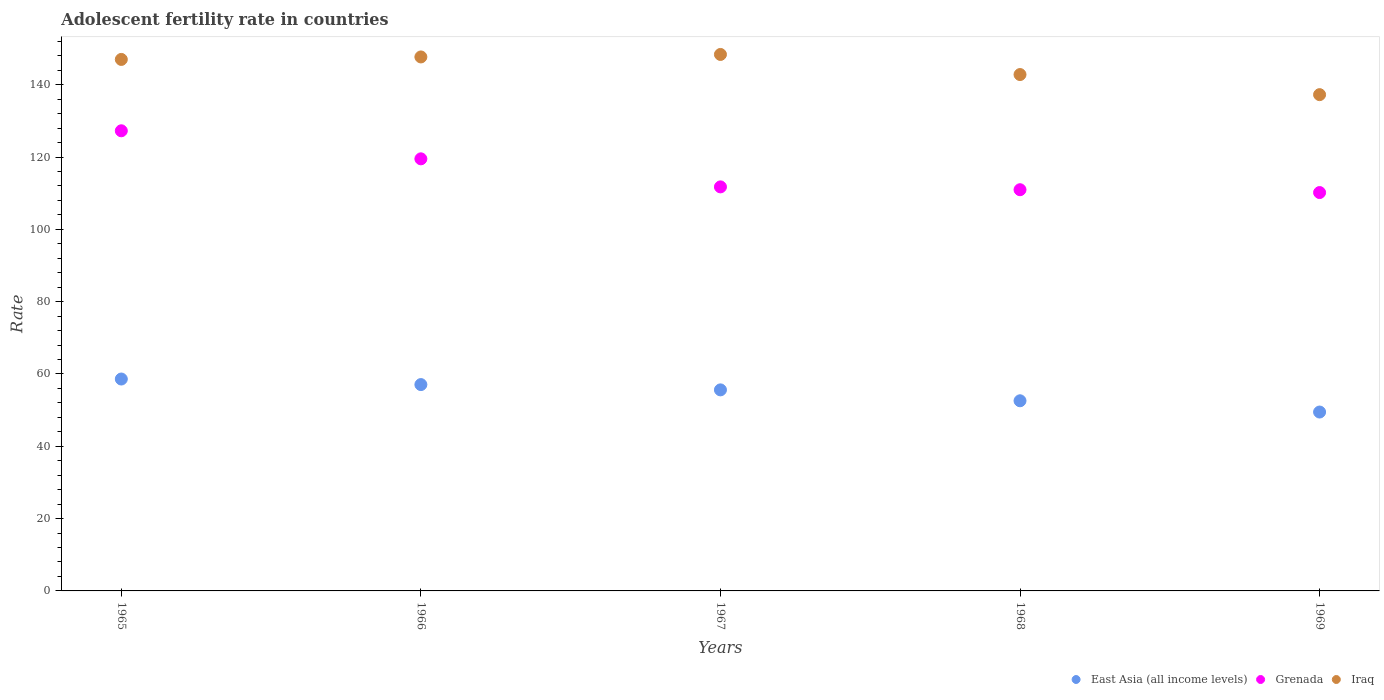What is the adolescent fertility rate in Grenada in 1967?
Provide a succinct answer. 111.74. Across all years, what is the maximum adolescent fertility rate in Grenada?
Your answer should be very brief. 127.26. Across all years, what is the minimum adolescent fertility rate in Iraq?
Your answer should be very brief. 137.25. In which year was the adolescent fertility rate in East Asia (all income levels) maximum?
Offer a very short reply. 1965. In which year was the adolescent fertility rate in Grenada minimum?
Offer a terse response. 1969. What is the total adolescent fertility rate in East Asia (all income levels) in the graph?
Provide a short and direct response. 273.33. What is the difference between the adolescent fertility rate in Grenada in 1965 and that in 1966?
Ensure brevity in your answer.  7.76. What is the difference between the adolescent fertility rate in Grenada in 1967 and the adolescent fertility rate in Iraq in 1968?
Keep it short and to the point. -31.07. What is the average adolescent fertility rate in Grenada per year?
Make the answer very short. 115.93. In the year 1969, what is the difference between the adolescent fertility rate in East Asia (all income levels) and adolescent fertility rate in Grenada?
Your response must be concise. -60.7. What is the ratio of the adolescent fertility rate in East Asia (all income levels) in 1967 to that in 1969?
Your answer should be compact. 1.12. Is the difference between the adolescent fertility rate in East Asia (all income levels) in 1965 and 1967 greater than the difference between the adolescent fertility rate in Grenada in 1965 and 1967?
Give a very brief answer. No. What is the difference between the highest and the second highest adolescent fertility rate in East Asia (all income levels)?
Keep it short and to the point. 1.54. What is the difference between the highest and the lowest adolescent fertility rate in Grenada?
Offer a terse response. 17.08. Is the sum of the adolescent fertility rate in Grenada in 1965 and 1968 greater than the maximum adolescent fertility rate in East Asia (all income levels) across all years?
Give a very brief answer. Yes. Is it the case that in every year, the sum of the adolescent fertility rate in Grenada and adolescent fertility rate in Iraq  is greater than the adolescent fertility rate in East Asia (all income levels)?
Your response must be concise. Yes. Does the adolescent fertility rate in Iraq monotonically increase over the years?
Ensure brevity in your answer.  No. Is the adolescent fertility rate in Iraq strictly greater than the adolescent fertility rate in East Asia (all income levels) over the years?
Provide a short and direct response. Yes. How many dotlines are there?
Provide a short and direct response. 3. What is the difference between two consecutive major ticks on the Y-axis?
Give a very brief answer. 20. Are the values on the major ticks of Y-axis written in scientific E-notation?
Your answer should be compact. No. Does the graph contain any zero values?
Your response must be concise. No. How are the legend labels stacked?
Your answer should be compact. Horizontal. What is the title of the graph?
Provide a succinct answer. Adolescent fertility rate in countries. Does "Moldova" appear as one of the legend labels in the graph?
Your response must be concise. No. What is the label or title of the X-axis?
Your response must be concise. Years. What is the label or title of the Y-axis?
Your answer should be compact. Rate. What is the Rate in East Asia (all income levels) in 1965?
Make the answer very short. 58.6. What is the Rate in Grenada in 1965?
Keep it short and to the point. 127.26. What is the Rate of Iraq in 1965?
Ensure brevity in your answer.  146.99. What is the Rate of East Asia (all income levels) in 1966?
Give a very brief answer. 57.07. What is the Rate in Grenada in 1966?
Your answer should be compact. 119.5. What is the Rate of Iraq in 1966?
Provide a succinct answer. 147.68. What is the Rate in East Asia (all income levels) in 1967?
Offer a terse response. 55.6. What is the Rate of Grenada in 1967?
Provide a short and direct response. 111.74. What is the Rate in Iraq in 1967?
Provide a short and direct response. 148.37. What is the Rate in East Asia (all income levels) in 1968?
Offer a very short reply. 52.59. What is the Rate of Grenada in 1968?
Your answer should be very brief. 110.96. What is the Rate in Iraq in 1968?
Your response must be concise. 142.81. What is the Rate in East Asia (all income levels) in 1969?
Your answer should be very brief. 49.47. What is the Rate in Grenada in 1969?
Provide a short and direct response. 110.18. What is the Rate of Iraq in 1969?
Your response must be concise. 137.25. Across all years, what is the maximum Rate in East Asia (all income levels)?
Provide a succinct answer. 58.6. Across all years, what is the maximum Rate of Grenada?
Ensure brevity in your answer.  127.26. Across all years, what is the maximum Rate of Iraq?
Your answer should be compact. 148.37. Across all years, what is the minimum Rate of East Asia (all income levels)?
Your response must be concise. 49.47. Across all years, what is the minimum Rate of Grenada?
Keep it short and to the point. 110.18. Across all years, what is the minimum Rate in Iraq?
Provide a succinct answer. 137.25. What is the total Rate of East Asia (all income levels) in the graph?
Your answer should be very brief. 273.33. What is the total Rate of Grenada in the graph?
Keep it short and to the point. 579.64. What is the total Rate of Iraq in the graph?
Your answer should be very brief. 723.11. What is the difference between the Rate in East Asia (all income levels) in 1965 and that in 1966?
Offer a terse response. 1.54. What is the difference between the Rate of Grenada in 1965 and that in 1966?
Your answer should be compact. 7.76. What is the difference between the Rate in Iraq in 1965 and that in 1966?
Ensure brevity in your answer.  -0.69. What is the difference between the Rate in East Asia (all income levels) in 1965 and that in 1967?
Your response must be concise. 3. What is the difference between the Rate in Grenada in 1965 and that in 1967?
Give a very brief answer. 15.51. What is the difference between the Rate of Iraq in 1965 and that in 1967?
Your answer should be very brief. -1.38. What is the difference between the Rate of East Asia (all income levels) in 1965 and that in 1968?
Keep it short and to the point. 6.02. What is the difference between the Rate of Grenada in 1965 and that in 1968?
Offer a very short reply. 16.3. What is the difference between the Rate of Iraq in 1965 and that in 1968?
Give a very brief answer. 4.18. What is the difference between the Rate of East Asia (all income levels) in 1965 and that in 1969?
Offer a terse response. 9.13. What is the difference between the Rate in Grenada in 1965 and that in 1969?
Ensure brevity in your answer.  17.08. What is the difference between the Rate of Iraq in 1965 and that in 1969?
Your answer should be very brief. 9.74. What is the difference between the Rate of East Asia (all income levels) in 1966 and that in 1967?
Your answer should be very brief. 1.46. What is the difference between the Rate in Grenada in 1966 and that in 1967?
Provide a short and direct response. 7.76. What is the difference between the Rate in Iraq in 1966 and that in 1967?
Ensure brevity in your answer.  -0.69. What is the difference between the Rate of East Asia (all income levels) in 1966 and that in 1968?
Give a very brief answer. 4.48. What is the difference between the Rate in Grenada in 1966 and that in 1968?
Your answer should be compact. 8.54. What is the difference between the Rate of Iraq in 1966 and that in 1968?
Give a very brief answer. 4.87. What is the difference between the Rate of East Asia (all income levels) in 1966 and that in 1969?
Provide a short and direct response. 7.59. What is the difference between the Rate of Grenada in 1966 and that in 1969?
Your response must be concise. 9.32. What is the difference between the Rate in Iraq in 1966 and that in 1969?
Provide a succinct answer. 10.43. What is the difference between the Rate of East Asia (all income levels) in 1967 and that in 1968?
Offer a terse response. 3.02. What is the difference between the Rate of Grenada in 1967 and that in 1968?
Your answer should be compact. 0.78. What is the difference between the Rate of Iraq in 1967 and that in 1968?
Keep it short and to the point. 5.56. What is the difference between the Rate in East Asia (all income levels) in 1967 and that in 1969?
Provide a short and direct response. 6.13. What is the difference between the Rate in Grenada in 1967 and that in 1969?
Your answer should be compact. 1.57. What is the difference between the Rate of Iraq in 1967 and that in 1969?
Your response must be concise. 11.12. What is the difference between the Rate in East Asia (all income levels) in 1968 and that in 1969?
Give a very brief answer. 3.11. What is the difference between the Rate of Grenada in 1968 and that in 1969?
Ensure brevity in your answer.  0.78. What is the difference between the Rate in Iraq in 1968 and that in 1969?
Offer a terse response. 5.56. What is the difference between the Rate in East Asia (all income levels) in 1965 and the Rate in Grenada in 1966?
Your answer should be compact. -60.9. What is the difference between the Rate of East Asia (all income levels) in 1965 and the Rate of Iraq in 1966?
Keep it short and to the point. -89.08. What is the difference between the Rate of Grenada in 1965 and the Rate of Iraq in 1966?
Offer a terse response. -20.42. What is the difference between the Rate in East Asia (all income levels) in 1965 and the Rate in Grenada in 1967?
Ensure brevity in your answer.  -53.14. What is the difference between the Rate in East Asia (all income levels) in 1965 and the Rate in Iraq in 1967?
Provide a short and direct response. -89.77. What is the difference between the Rate of Grenada in 1965 and the Rate of Iraq in 1967?
Make the answer very short. -21.11. What is the difference between the Rate in East Asia (all income levels) in 1965 and the Rate in Grenada in 1968?
Keep it short and to the point. -52.36. What is the difference between the Rate of East Asia (all income levels) in 1965 and the Rate of Iraq in 1968?
Your answer should be very brief. -84.21. What is the difference between the Rate in Grenada in 1965 and the Rate in Iraq in 1968?
Offer a terse response. -15.55. What is the difference between the Rate in East Asia (all income levels) in 1965 and the Rate in Grenada in 1969?
Your answer should be compact. -51.57. What is the difference between the Rate in East Asia (all income levels) in 1965 and the Rate in Iraq in 1969?
Provide a short and direct response. -78.65. What is the difference between the Rate in Grenada in 1965 and the Rate in Iraq in 1969?
Give a very brief answer. -10. What is the difference between the Rate of East Asia (all income levels) in 1966 and the Rate of Grenada in 1967?
Keep it short and to the point. -54.68. What is the difference between the Rate in East Asia (all income levels) in 1966 and the Rate in Iraq in 1967?
Offer a very short reply. -91.3. What is the difference between the Rate of Grenada in 1966 and the Rate of Iraq in 1967?
Offer a terse response. -28.87. What is the difference between the Rate of East Asia (all income levels) in 1966 and the Rate of Grenada in 1968?
Give a very brief answer. -53.89. What is the difference between the Rate of East Asia (all income levels) in 1966 and the Rate of Iraq in 1968?
Your answer should be compact. -85.75. What is the difference between the Rate of Grenada in 1966 and the Rate of Iraq in 1968?
Provide a short and direct response. -23.31. What is the difference between the Rate of East Asia (all income levels) in 1966 and the Rate of Grenada in 1969?
Keep it short and to the point. -53.11. What is the difference between the Rate of East Asia (all income levels) in 1966 and the Rate of Iraq in 1969?
Make the answer very short. -80.19. What is the difference between the Rate in Grenada in 1966 and the Rate in Iraq in 1969?
Keep it short and to the point. -17.75. What is the difference between the Rate of East Asia (all income levels) in 1967 and the Rate of Grenada in 1968?
Make the answer very short. -55.36. What is the difference between the Rate in East Asia (all income levels) in 1967 and the Rate in Iraq in 1968?
Ensure brevity in your answer.  -87.21. What is the difference between the Rate of Grenada in 1967 and the Rate of Iraq in 1968?
Make the answer very short. -31.07. What is the difference between the Rate in East Asia (all income levels) in 1967 and the Rate in Grenada in 1969?
Provide a short and direct response. -54.57. What is the difference between the Rate in East Asia (all income levels) in 1967 and the Rate in Iraq in 1969?
Provide a short and direct response. -81.65. What is the difference between the Rate of Grenada in 1967 and the Rate of Iraq in 1969?
Offer a terse response. -25.51. What is the difference between the Rate in East Asia (all income levels) in 1968 and the Rate in Grenada in 1969?
Provide a short and direct response. -57.59. What is the difference between the Rate in East Asia (all income levels) in 1968 and the Rate in Iraq in 1969?
Make the answer very short. -84.67. What is the difference between the Rate in Grenada in 1968 and the Rate in Iraq in 1969?
Provide a succinct answer. -26.29. What is the average Rate of East Asia (all income levels) per year?
Your response must be concise. 54.67. What is the average Rate in Grenada per year?
Provide a succinct answer. 115.93. What is the average Rate of Iraq per year?
Ensure brevity in your answer.  144.62. In the year 1965, what is the difference between the Rate of East Asia (all income levels) and Rate of Grenada?
Your answer should be compact. -68.65. In the year 1965, what is the difference between the Rate in East Asia (all income levels) and Rate in Iraq?
Make the answer very short. -88.39. In the year 1965, what is the difference between the Rate of Grenada and Rate of Iraq?
Offer a very short reply. -19.74. In the year 1966, what is the difference between the Rate of East Asia (all income levels) and Rate of Grenada?
Provide a succinct answer. -62.44. In the year 1966, what is the difference between the Rate in East Asia (all income levels) and Rate in Iraq?
Provide a succinct answer. -90.62. In the year 1966, what is the difference between the Rate in Grenada and Rate in Iraq?
Keep it short and to the point. -28.18. In the year 1967, what is the difference between the Rate in East Asia (all income levels) and Rate in Grenada?
Offer a terse response. -56.14. In the year 1967, what is the difference between the Rate in East Asia (all income levels) and Rate in Iraq?
Your answer should be very brief. -92.77. In the year 1967, what is the difference between the Rate of Grenada and Rate of Iraq?
Keep it short and to the point. -36.63. In the year 1968, what is the difference between the Rate in East Asia (all income levels) and Rate in Grenada?
Ensure brevity in your answer.  -58.37. In the year 1968, what is the difference between the Rate of East Asia (all income levels) and Rate of Iraq?
Give a very brief answer. -90.22. In the year 1968, what is the difference between the Rate of Grenada and Rate of Iraq?
Keep it short and to the point. -31.85. In the year 1969, what is the difference between the Rate of East Asia (all income levels) and Rate of Grenada?
Your answer should be compact. -60.7. In the year 1969, what is the difference between the Rate in East Asia (all income levels) and Rate in Iraq?
Your answer should be compact. -87.78. In the year 1969, what is the difference between the Rate in Grenada and Rate in Iraq?
Your answer should be very brief. -27.08. What is the ratio of the Rate of East Asia (all income levels) in 1965 to that in 1966?
Provide a succinct answer. 1.03. What is the ratio of the Rate in Grenada in 1965 to that in 1966?
Your response must be concise. 1.06. What is the ratio of the Rate of East Asia (all income levels) in 1965 to that in 1967?
Make the answer very short. 1.05. What is the ratio of the Rate in Grenada in 1965 to that in 1967?
Give a very brief answer. 1.14. What is the ratio of the Rate of East Asia (all income levels) in 1965 to that in 1968?
Your answer should be compact. 1.11. What is the ratio of the Rate in Grenada in 1965 to that in 1968?
Your answer should be very brief. 1.15. What is the ratio of the Rate in Iraq in 1965 to that in 1968?
Make the answer very short. 1.03. What is the ratio of the Rate in East Asia (all income levels) in 1965 to that in 1969?
Keep it short and to the point. 1.18. What is the ratio of the Rate in Grenada in 1965 to that in 1969?
Make the answer very short. 1.16. What is the ratio of the Rate of Iraq in 1965 to that in 1969?
Give a very brief answer. 1.07. What is the ratio of the Rate in East Asia (all income levels) in 1966 to that in 1967?
Your answer should be very brief. 1.03. What is the ratio of the Rate in Grenada in 1966 to that in 1967?
Keep it short and to the point. 1.07. What is the ratio of the Rate of East Asia (all income levels) in 1966 to that in 1968?
Provide a short and direct response. 1.09. What is the ratio of the Rate of Grenada in 1966 to that in 1968?
Provide a succinct answer. 1.08. What is the ratio of the Rate in Iraq in 1966 to that in 1968?
Your response must be concise. 1.03. What is the ratio of the Rate in East Asia (all income levels) in 1966 to that in 1969?
Provide a short and direct response. 1.15. What is the ratio of the Rate of Grenada in 1966 to that in 1969?
Offer a very short reply. 1.08. What is the ratio of the Rate in Iraq in 1966 to that in 1969?
Make the answer very short. 1.08. What is the ratio of the Rate in East Asia (all income levels) in 1967 to that in 1968?
Your answer should be compact. 1.06. What is the ratio of the Rate in Grenada in 1967 to that in 1968?
Your response must be concise. 1.01. What is the ratio of the Rate of Iraq in 1967 to that in 1968?
Your answer should be very brief. 1.04. What is the ratio of the Rate of East Asia (all income levels) in 1967 to that in 1969?
Give a very brief answer. 1.12. What is the ratio of the Rate in Grenada in 1967 to that in 1969?
Offer a terse response. 1.01. What is the ratio of the Rate in Iraq in 1967 to that in 1969?
Offer a terse response. 1.08. What is the ratio of the Rate in East Asia (all income levels) in 1968 to that in 1969?
Ensure brevity in your answer.  1.06. What is the ratio of the Rate of Grenada in 1968 to that in 1969?
Offer a very short reply. 1.01. What is the ratio of the Rate in Iraq in 1968 to that in 1969?
Ensure brevity in your answer.  1.04. What is the difference between the highest and the second highest Rate of East Asia (all income levels)?
Your response must be concise. 1.54. What is the difference between the highest and the second highest Rate of Grenada?
Ensure brevity in your answer.  7.76. What is the difference between the highest and the second highest Rate of Iraq?
Offer a very short reply. 0.69. What is the difference between the highest and the lowest Rate of East Asia (all income levels)?
Make the answer very short. 9.13. What is the difference between the highest and the lowest Rate of Grenada?
Your response must be concise. 17.08. What is the difference between the highest and the lowest Rate in Iraq?
Make the answer very short. 11.12. 